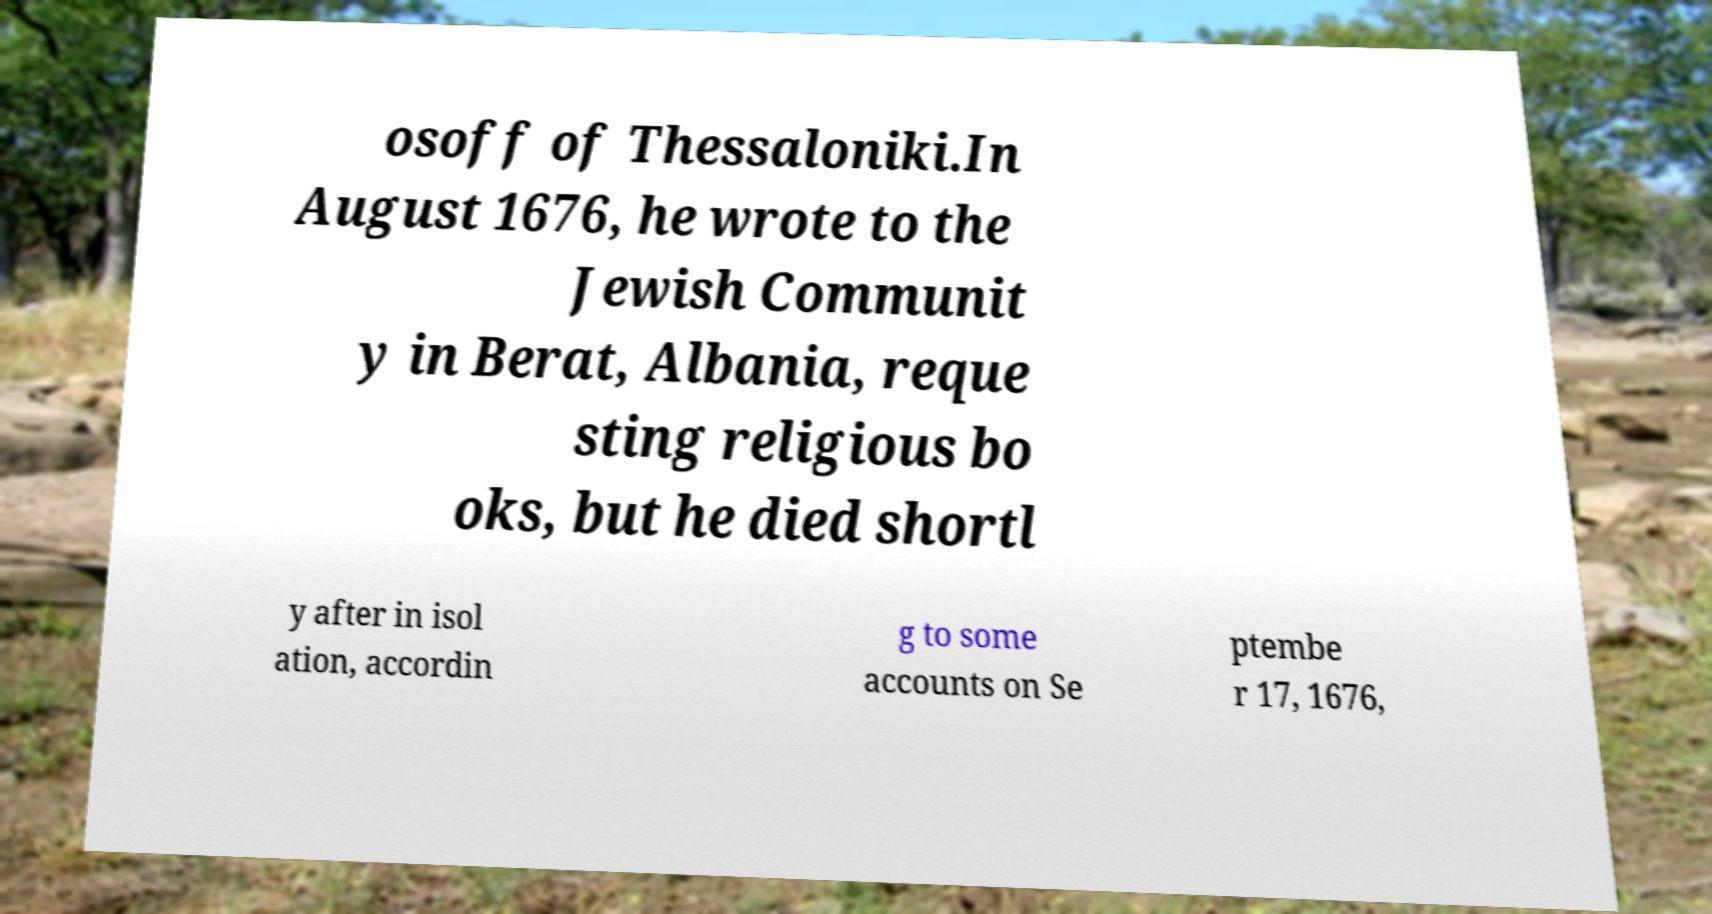What messages or text are displayed in this image? I need them in a readable, typed format. osoff of Thessaloniki.In August 1676, he wrote to the Jewish Communit y in Berat, Albania, reque sting religious bo oks, but he died shortl y after in isol ation, accordin g to some accounts on Se ptembe r 17, 1676, 